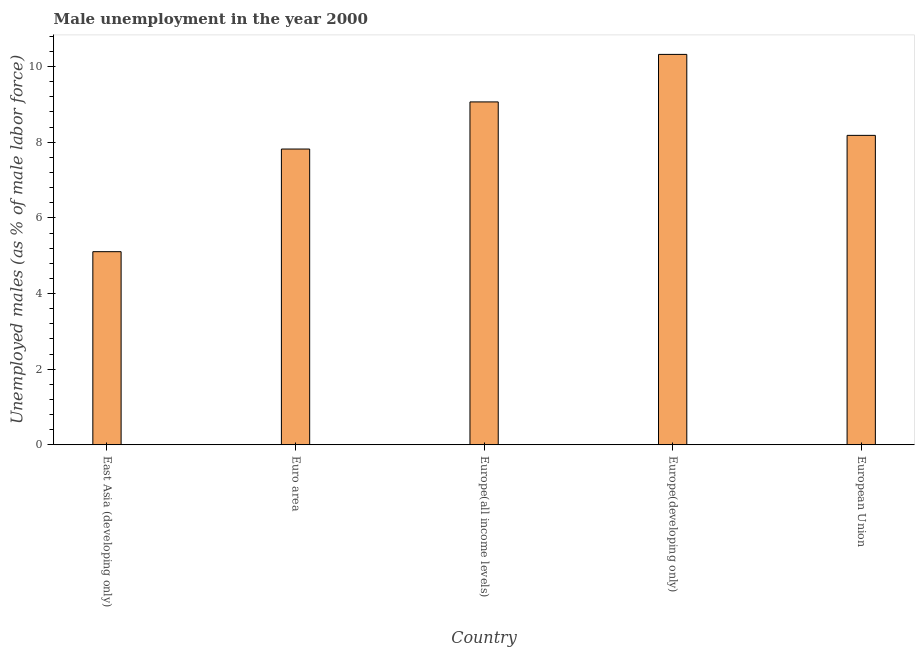What is the title of the graph?
Your answer should be compact. Male unemployment in the year 2000. What is the label or title of the Y-axis?
Your answer should be very brief. Unemployed males (as % of male labor force). What is the unemployed males population in European Union?
Give a very brief answer. 8.18. Across all countries, what is the maximum unemployed males population?
Offer a terse response. 10.32. Across all countries, what is the minimum unemployed males population?
Your answer should be compact. 5.11. In which country was the unemployed males population maximum?
Keep it short and to the point. Europe(developing only). In which country was the unemployed males population minimum?
Provide a succinct answer. East Asia (developing only). What is the sum of the unemployed males population?
Make the answer very short. 40.5. What is the difference between the unemployed males population in East Asia (developing only) and Euro area?
Provide a short and direct response. -2.71. What is the average unemployed males population per country?
Give a very brief answer. 8.1. What is the median unemployed males population?
Offer a terse response. 8.18. In how many countries, is the unemployed males population greater than 6.8 %?
Provide a succinct answer. 4. What is the ratio of the unemployed males population in East Asia (developing only) to that in Euro area?
Your answer should be compact. 0.65. Is the unemployed males population in Europe(all income levels) less than that in European Union?
Offer a very short reply. No. Is the difference between the unemployed males population in East Asia (developing only) and European Union greater than the difference between any two countries?
Your response must be concise. No. What is the difference between the highest and the second highest unemployed males population?
Provide a succinct answer. 1.26. What is the difference between the highest and the lowest unemployed males population?
Give a very brief answer. 5.22. In how many countries, is the unemployed males population greater than the average unemployed males population taken over all countries?
Make the answer very short. 3. What is the difference between two consecutive major ticks on the Y-axis?
Provide a succinct answer. 2. Are the values on the major ticks of Y-axis written in scientific E-notation?
Keep it short and to the point. No. What is the Unemployed males (as % of male labor force) of East Asia (developing only)?
Offer a very short reply. 5.11. What is the Unemployed males (as % of male labor force) in Euro area?
Provide a short and direct response. 7.82. What is the Unemployed males (as % of male labor force) of Europe(all income levels)?
Your response must be concise. 9.07. What is the Unemployed males (as % of male labor force) of Europe(developing only)?
Your answer should be compact. 10.32. What is the Unemployed males (as % of male labor force) of European Union?
Provide a short and direct response. 8.18. What is the difference between the Unemployed males (as % of male labor force) in East Asia (developing only) and Euro area?
Offer a terse response. -2.71. What is the difference between the Unemployed males (as % of male labor force) in East Asia (developing only) and Europe(all income levels)?
Keep it short and to the point. -3.96. What is the difference between the Unemployed males (as % of male labor force) in East Asia (developing only) and Europe(developing only)?
Make the answer very short. -5.22. What is the difference between the Unemployed males (as % of male labor force) in East Asia (developing only) and European Union?
Offer a terse response. -3.08. What is the difference between the Unemployed males (as % of male labor force) in Euro area and Europe(all income levels)?
Offer a terse response. -1.25. What is the difference between the Unemployed males (as % of male labor force) in Euro area and Europe(developing only)?
Ensure brevity in your answer.  -2.5. What is the difference between the Unemployed males (as % of male labor force) in Euro area and European Union?
Make the answer very short. -0.36. What is the difference between the Unemployed males (as % of male labor force) in Europe(all income levels) and Europe(developing only)?
Your answer should be very brief. -1.26. What is the difference between the Unemployed males (as % of male labor force) in Europe(all income levels) and European Union?
Keep it short and to the point. 0.88. What is the difference between the Unemployed males (as % of male labor force) in Europe(developing only) and European Union?
Make the answer very short. 2.14. What is the ratio of the Unemployed males (as % of male labor force) in East Asia (developing only) to that in Euro area?
Provide a succinct answer. 0.65. What is the ratio of the Unemployed males (as % of male labor force) in East Asia (developing only) to that in Europe(all income levels)?
Keep it short and to the point. 0.56. What is the ratio of the Unemployed males (as % of male labor force) in East Asia (developing only) to that in Europe(developing only)?
Give a very brief answer. 0.49. What is the ratio of the Unemployed males (as % of male labor force) in East Asia (developing only) to that in European Union?
Keep it short and to the point. 0.62. What is the ratio of the Unemployed males (as % of male labor force) in Euro area to that in Europe(all income levels)?
Give a very brief answer. 0.86. What is the ratio of the Unemployed males (as % of male labor force) in Euro area to that in Europe(developing only)?
Your answer should be compact. 0.76. What is the ratio of the Unemployed males (as % of male labor force) in Euro area to that in European Union?
Offer a terse response. 0.96. What is the ratio of the Unemployed males (as % of male labor force) in Europe(all income levels) to that in Europe(developing only)?
Provide a succinct answer. 0.88. What is the ratio of the Unemployed males (as % of male labor force) in Europe(all income levels) to that in European Union?
Ensure brevity in your answer.  1.11. What is the ratio of the Unemployed males (as % of male labor force) in Europe(developing only) to that in European Union?
Provide a short and direct response. 1.26. 